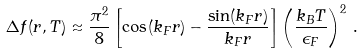<formula> <loc_0><loc_0><loc_500><loc_500>\Delta f ( r , T ) \approx \frac { \pi ^ { 2 } } { 8 } \left [ \cos ( k _ { F } r ) - \frac { \sin ( k _ { F } r ) } { k _ { F } r } \right ] \left ( \frac { k _ { B } T } { \epsilon _ { F } } \right ) ^ { 2 } \, .</formula> 